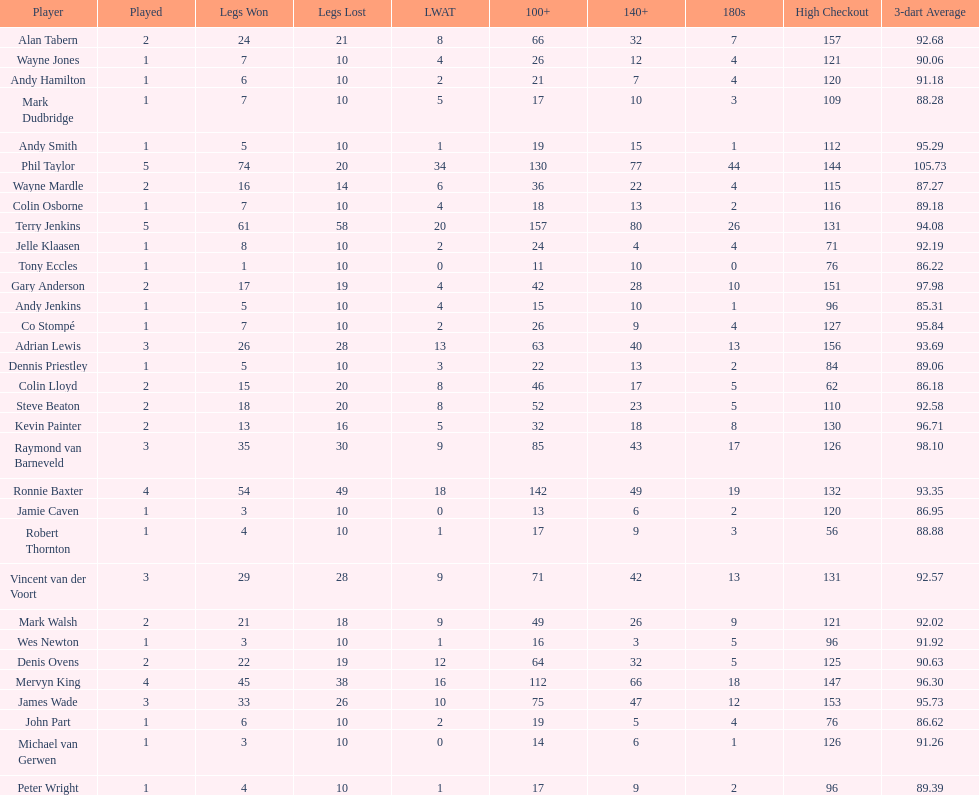Which player lost the least? Co Stompé, Andy Smith, Jelle Klaasen, Wes Newton, Michael van Gerwen, Andy Hamilton, Wayne Jones, Peter Wright, Colin Osborne, Dennis Priestley, Robert Thornton, Mark Dudbridge, Jamie Caven, John Part, Tony Eccles, Andy Jenkins. 